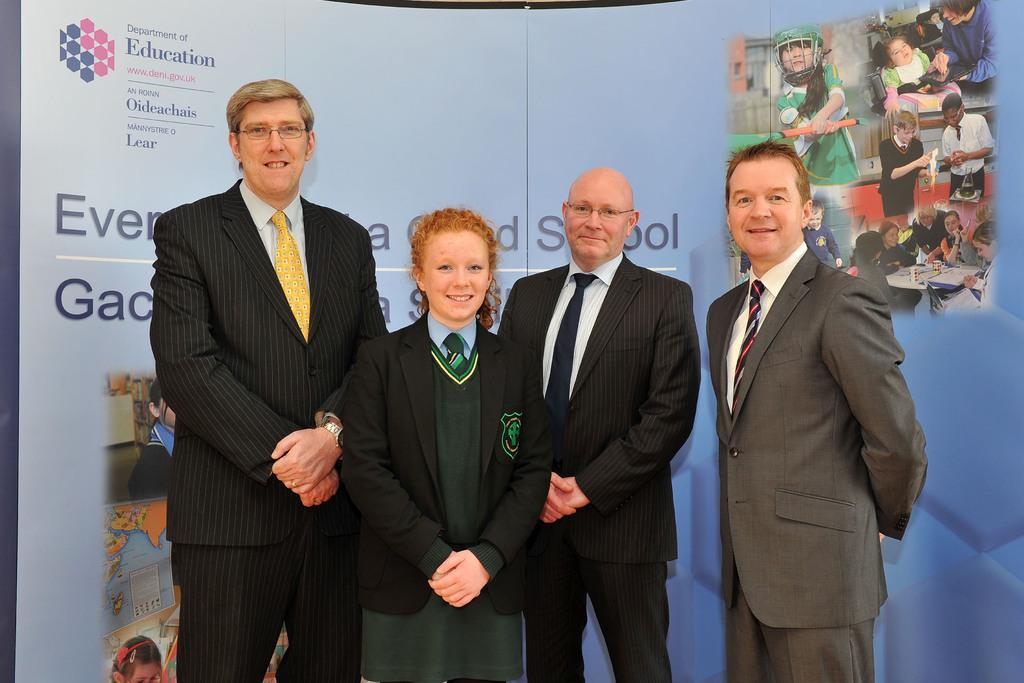Please provide a concise description of this image. In this picture I can see there are four people standing here and smiling. Among them one girl is standing here and the other persons are wearing blazers and in the backdrop there is a banner and there are pictures and name written on it. 